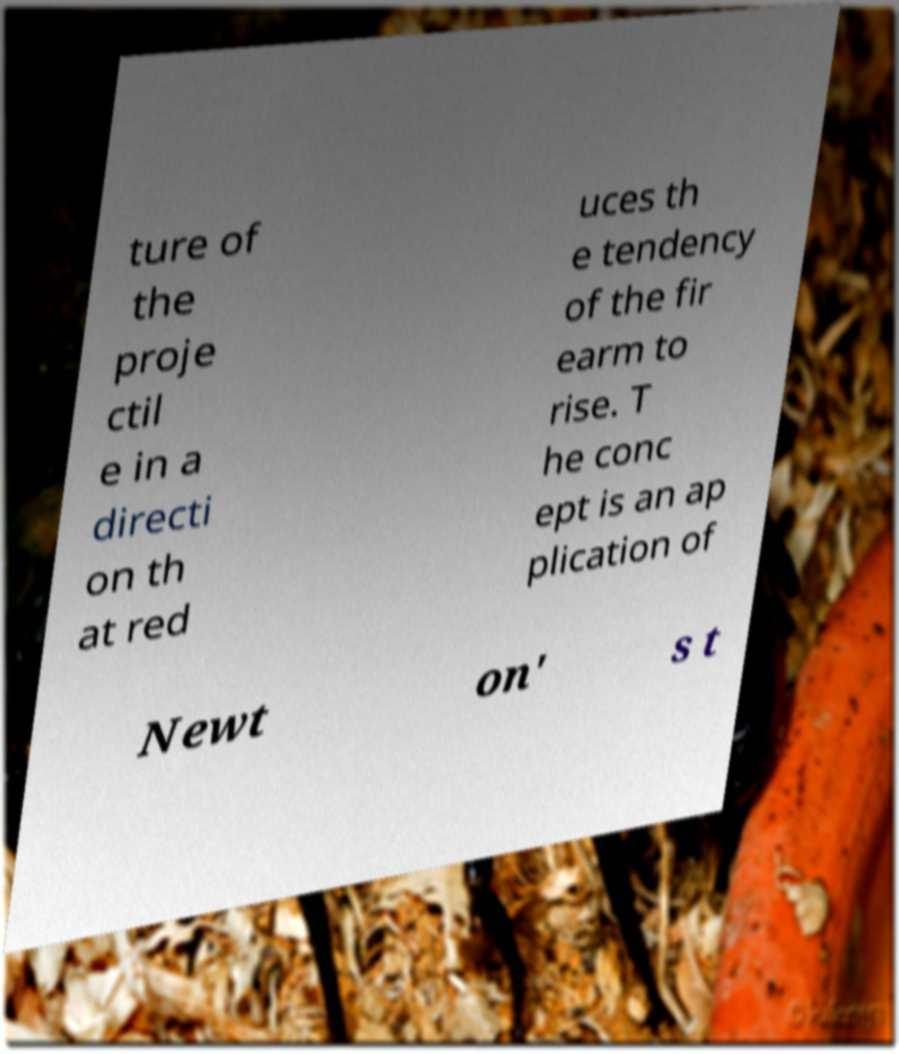There's text embedded in this image that I need extracted. Can you transcribe it verbatim? ture of the proje ctil e in a directi on th at red uces th e tendency of the fir earm to rise. T he conc ept is an ap plication of Newt on' s t 